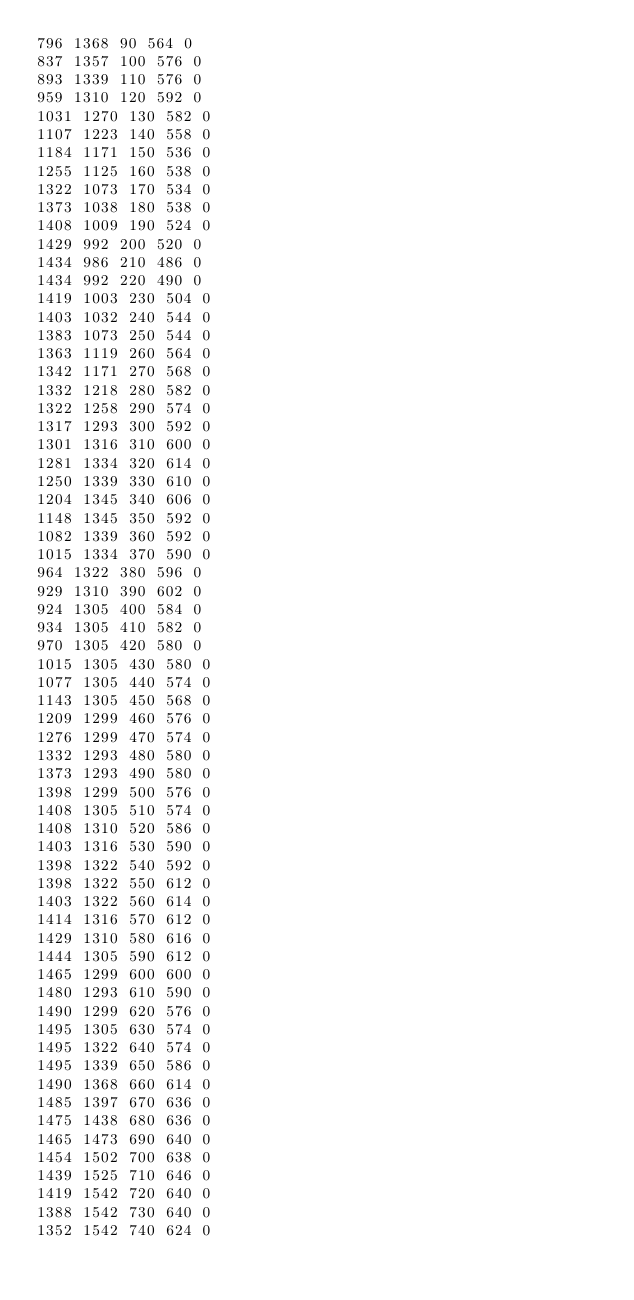<code> <loc_0><loc_0><loc_500><loc_500><_SML_>796 1368 90 564 0
837 1357 100 576 0
893 1339 110 576 0
959 1310 120 592 0
1031 1270 130 582 0
1107 1223 140 558 0
1184 1171 150 536 0
1255 1125 160 538 0
1322 1073 170 534 0
1373 1038 180 538 0
1408 1009 190 524 0
1429 992 200 520 0
1434 986 210 486 0
1434 992 220 490 0
1419 1003 230 504 0
1403 1032 240 544 0
1383 1073 250 544 0
1363 1119 260 564 0
1342 1171 270 568 0
1332 1218 280 582 0
1322 1258 290 574 0
1317 1293 300 592 0
1301 1316 310 600 0
1281 1334 320 614 0
1250 1339 330 610 0
1204 1345 340 606 0
1148 1345 350 592 0
1082 1339 360 592 0
1015 1334 370 590 0
964 1322 380 596 0
929 1310 390 602 0
924 1305 400 584 0
934 1305 410 582 0
970 1305 420 580 0
1015 1305 430 580 0
1077 1305 440 574 0
1143 1305 450 568 0
1209 1299 460 576 0
1276 1299 470 574 0
1332 1293 480 580 0
1373 1293 490 580 0
1398 1299 500 576 0
1408 1305 510 574 0
1408 1310 520 586 0
1403 1316 530 590 0
1398 1322 540 592 0
1398 1322 550 612 0
1403 1322 560 614 0
1414 1316 570 612 0
1429 1310 580 616 0
1444 1305 590 612 0
1465 1299 600 600 0
1480 1293 610 590 0
1490 1299 620 576 0
1495 1305 630 574 0
1495 1322 640 574 0
1495 1339 650 586 0
1490 1368 660 614 0
1485 1397 670 636 0
1475 1438 680 636 0
1465 1473 690 640 0
1454 1502 700 638 0
1439 1525 710 646 0
1419 1542 720 640 0
1388 1542 730 640 0
1352 1542 740 624 0</code> 